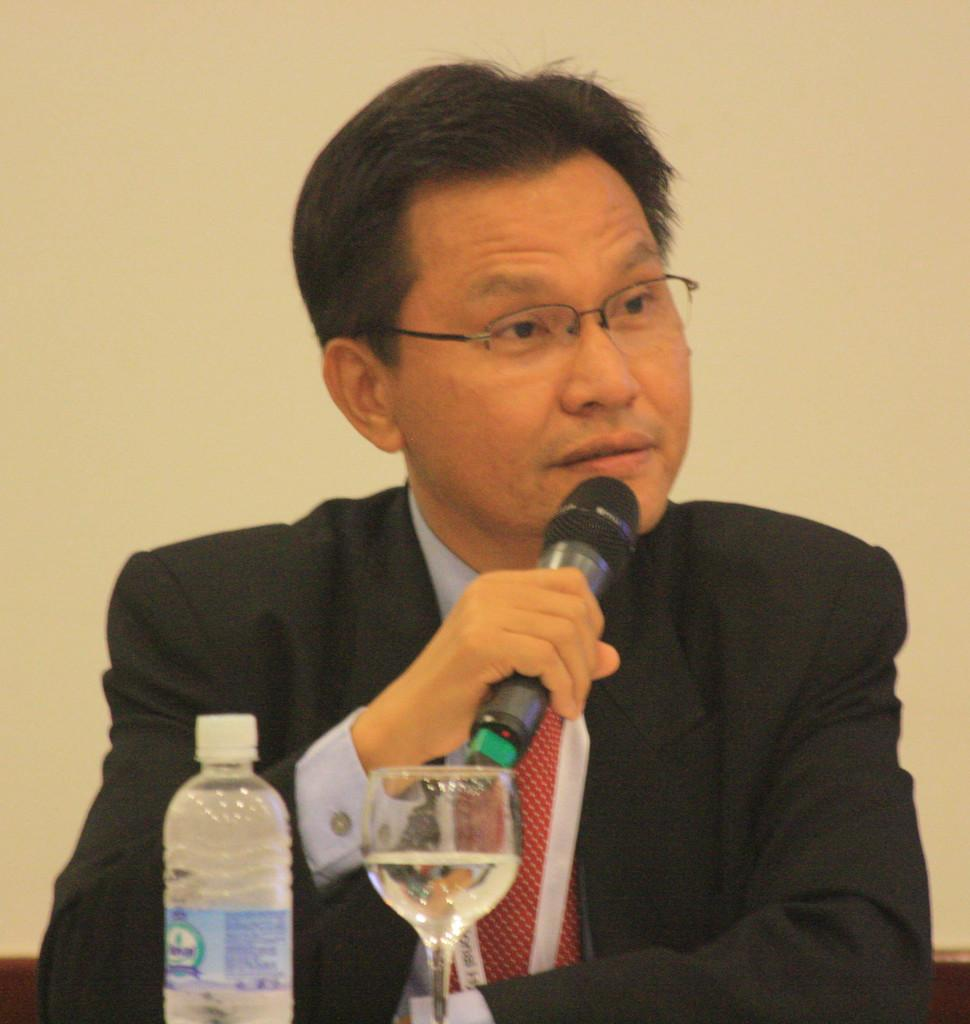What is the person in the image doing? The person is sitting on a chair and holding a mic. What is the person wearing? The person is wearing a black jacket and spectacles. What objects can be seen on the table in the image? There is a glass and a bottle on the table. How many times does the person laugh in the image? The image does not show the person laughing, so it cannot be determined how many times they laugh. 